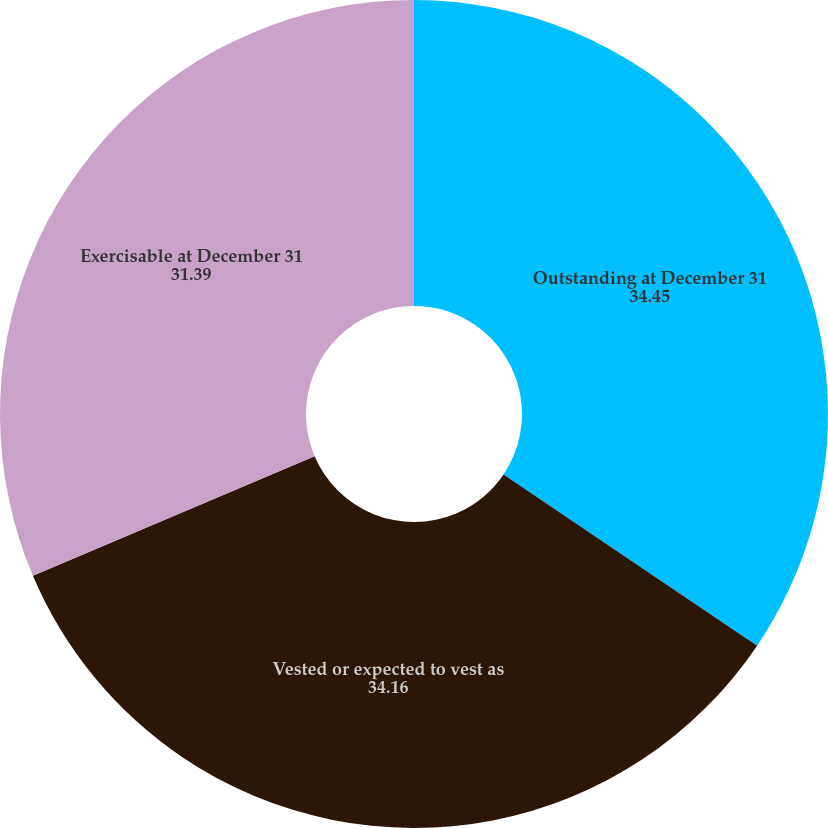Convert chart. <chart><loc_0><loc_0><loc_500><loc_500><pie_chart><fcel>Outstanding at December 31<fcel>Vested or expected to vest as<fcel>Exercisable at December 31<nl><fcel>34.45%<fcel>34.16%<fcel>31.39%<nl></chart> 